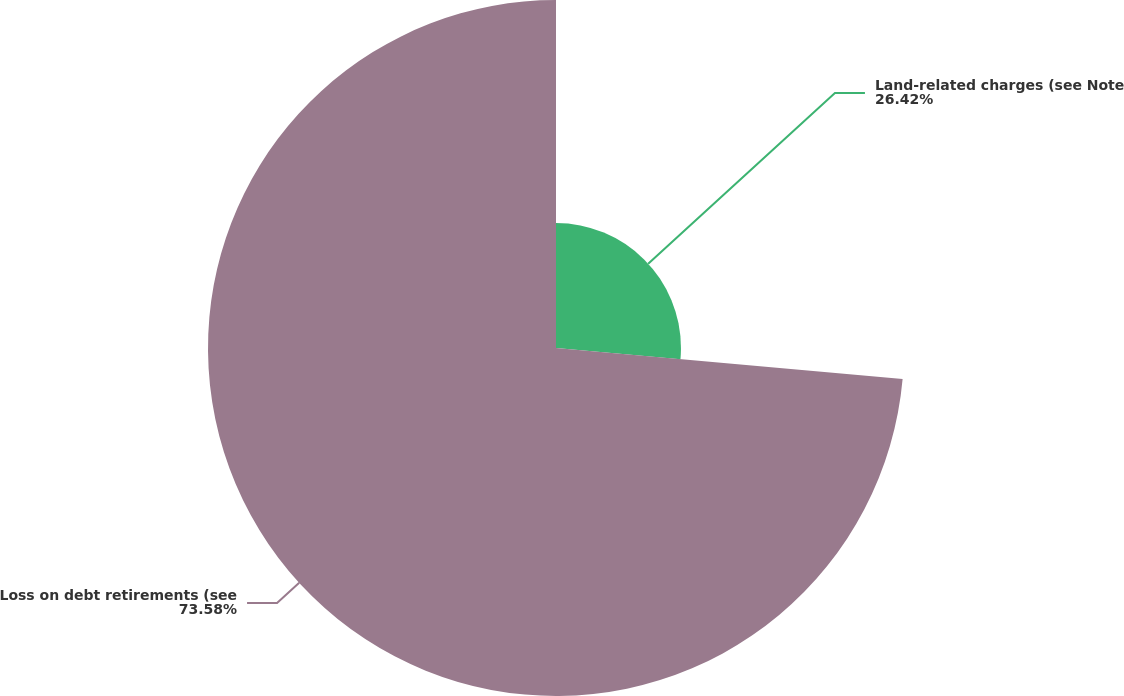<chart> <loc_0><loc_0><loc_500><loc_500><pie_chart><fcel>Land-related charges (see Note<fcel>Loss on debt retirements (see<nl><fcel>26.42%<fcel>73.58%<nl></chart> 